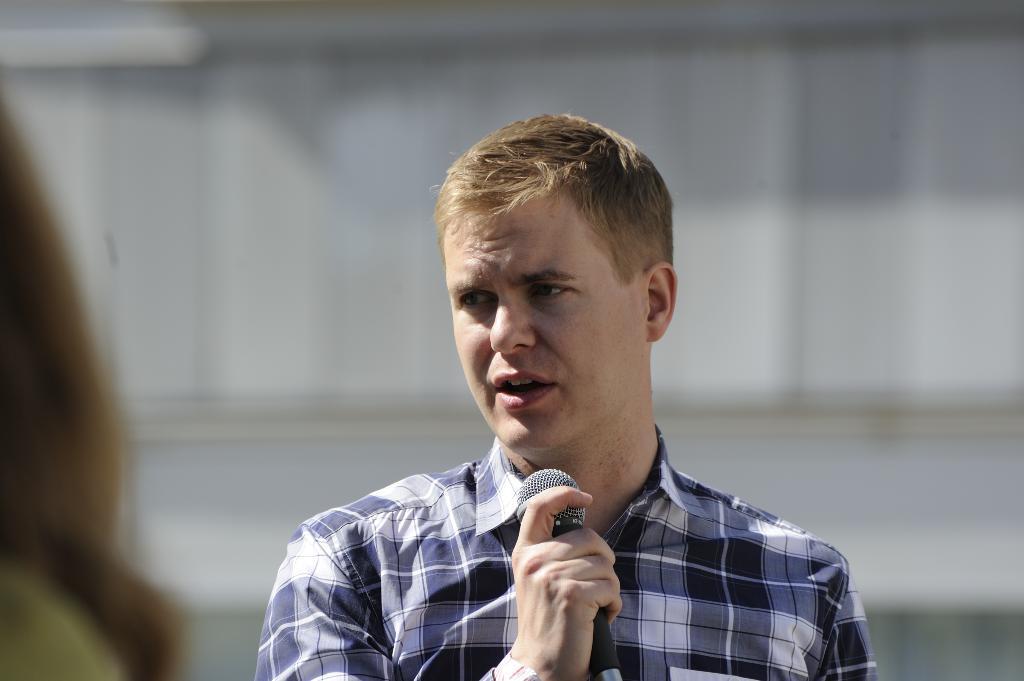Can you describe this image briefly? In this image we can see a man standing and wearing a blue shirt, and holding a microphone in the hand, and at here a person is standing. 